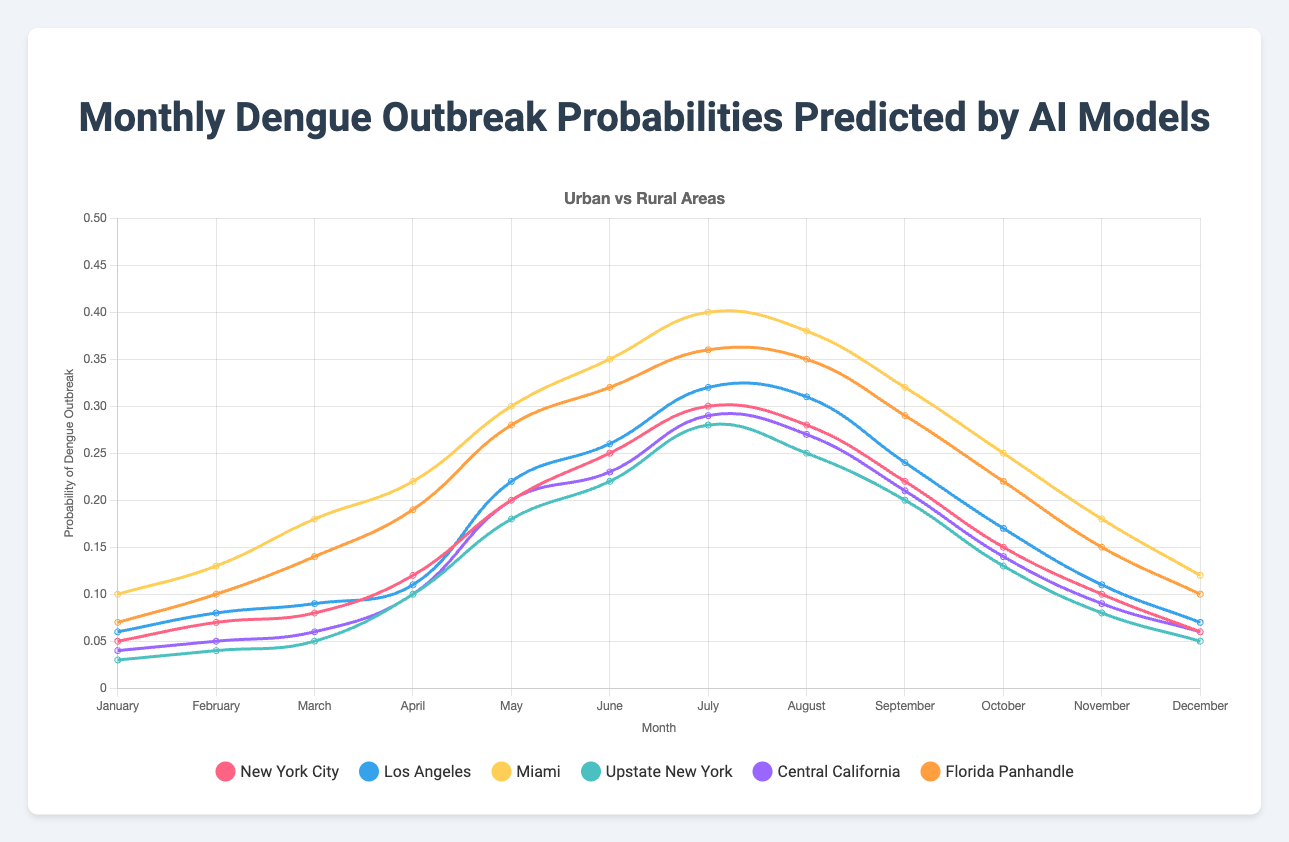What is the probability of a dengue outbreak in Miami during July? First, find the line for Miami. Look for the value corresponding to July. The plot shows a probability value for each month. For July, the value is 0.40.
Answer: 0.40 Which area has the highest probability of a dengue outbreak in April, and what is that probability? Examine the plot for April's data points. Miami shows the highest value. The probability for Miami in April is 0.22.
Answer: Miami, 0.22 Compare the dengue outbreak probabilities between New York City and Upstate New York in June. Which area has a higher probability, and by how much? Identify the lines for New York City and Upstate New York in June. New York City has a probability of 0.25, and Upstate New York has 0.22. Subtract 0.22 from 0.25 to get the difference.
Answer: New York City, by 0.03 What is the average dengue outbreak probability in Urban areas during May? Find the probabilities for New York City (0.20), Los Angeles (0.22), and Miami (0.30) in May. Sum them up (0.20 + 0.22 + 0.30 = 0.72) and divide by the number of cities (3). The average is 0.72/3 = 0.24.
Answer: 0.24 Which month shows the least difference in dengue outbreak probabilities between Central California and Florida Panhandle, and what is that difference? Examine each month's probabilities for Central California and Florida Panhandle. Compare differences (absolute values). March shows the least difference: Central California (0.06) and Florida Panhandle (0.14). The difference is
Answer: March, 0.08 Over the year, which city has the most significant fluctuation in predicted probabilities for dengue outbreaks? Look at the range of values for each city across the months. Miami ranges from 0.10 to 0.40, which is a range of 0.30, the largest among all cities.
Answer: Miami In November, which area—Los Angeles or Central California—has a higher probability, and how significant is the difference? Check the lines for Los Angeles and Central California in November. Los Angeles has 0.11, and Central California has 0.09. The difference is 0.11 - 0.09 = 0.02.
Answer: Los Angeles, 0.02 What is the probability difference of dengue outbreaks between the highest and lowest points in New York City throughout the year? Identify the highest and lowest points for New York City. The highest is 0.30 (July), and the lowest is 0.05 (January). The difference is 0.30 - 0.05 = 0.25.
Answer: 0.25 During which month does Upstate New York experience the highest probability of a dengue outbreak? Follow the line for Upstate New York to find the peak value. The highest probability occurs in July with a value of 0.28.
Answer: July What is the combined probability of dengue outbreaks in Florida Panhandle in February and March? Look for February and March values for Florida Panhandle. In February, it is 0.10; in March, it is 0.14. Add these values (0.10 + 0.14 = 0.24).
Answer: 0.24 